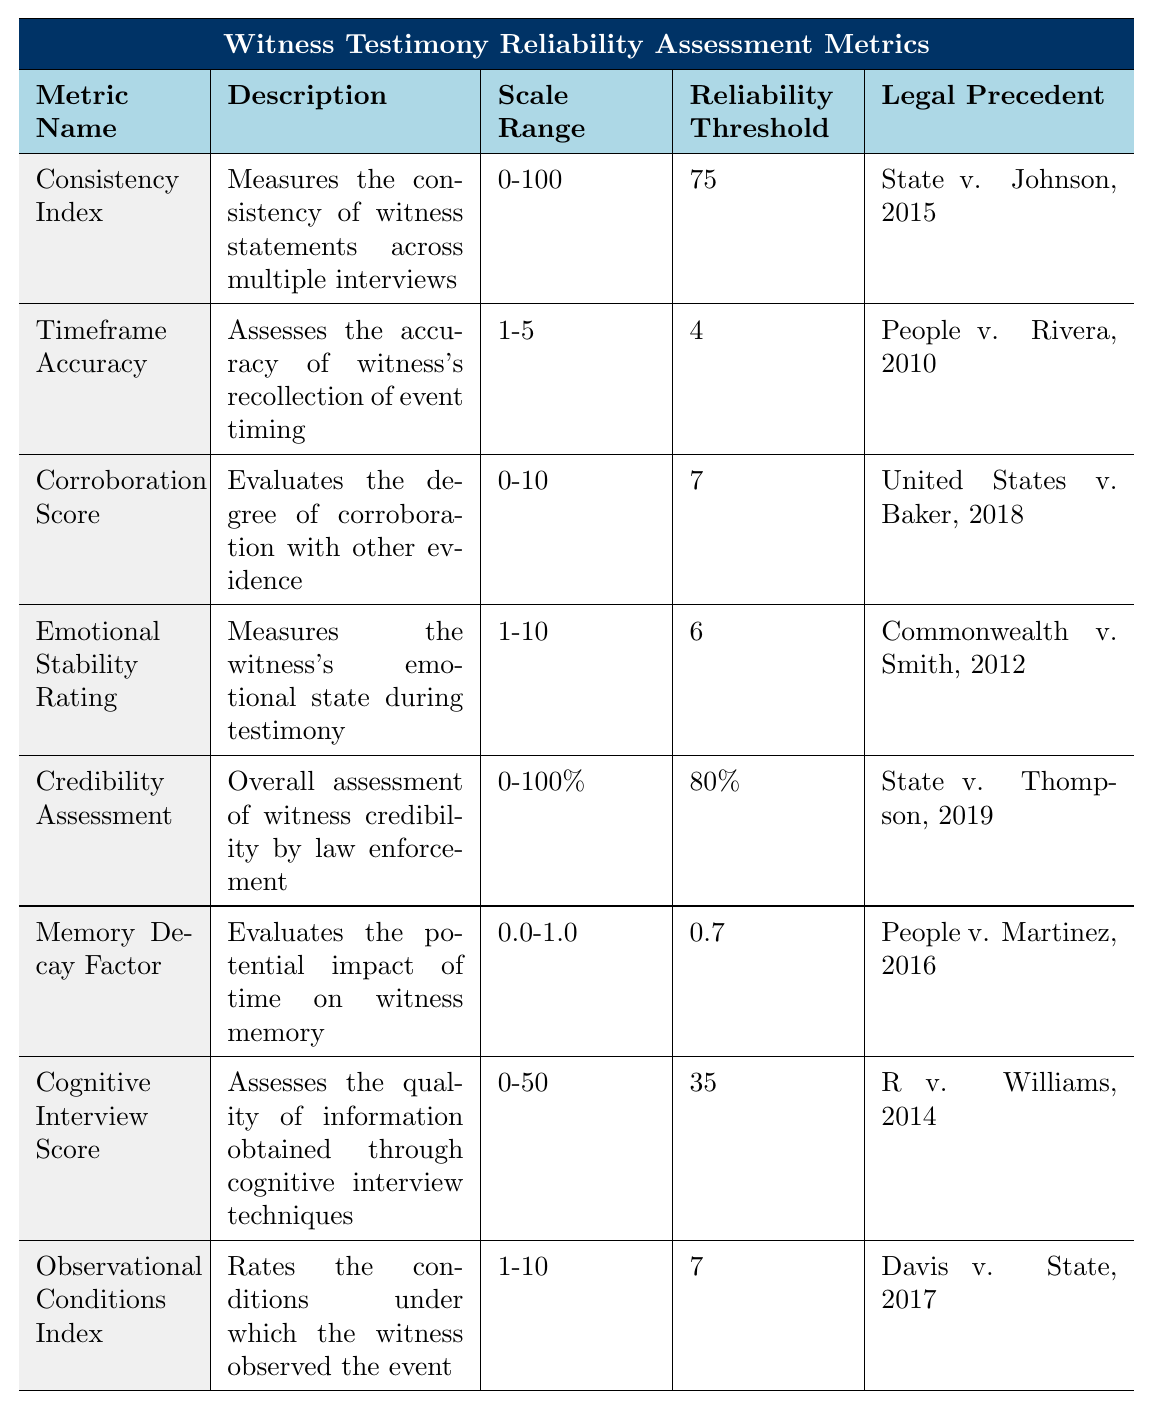What is the highest reliability threshold listed in the table? The highest reliability threshold is 80%, which is indicated in the "Credibility Assessment" metric.
Answer: 80% Which metric measures the conditions under which the witness observed the event? The metric that measures the conditions is the "Observational Conditions Index."
Answer: Observational Conditions Index How many metrics have a reliability threshold of 7 or higher? The metrics with reliability thresholds of 7 or higher are the "Consistency Index," "Corroboration Score," "Observational Conditions Index," and "Credibility Assessment," totaling 4 metrics.
Answer: 4 Is the "Emotional Stability Rating" scored on a scale of 0-10? No, the "Emotional Stability Rating" is scored on a scale of 1-10.
Answer: No What metric has a lower reliability threshold, "Cognitive Interview Score" or "Timeframe Accuracy"? The "Cognitive Interview Score" has a reliability threshold of 35, while "Timeframe Accuracy" has 4. Since we are comparing scores of different types, we conclude with the given values: 35 is lower than 4 in its respective range (0-50). Thus, the "Timeframe Accuracy" metrics have the lower figure.
Answer: Timeframe Accuracy Which metric's description most closely relates to how time affects a witness's memory? The "Memory Decay Factor" specifically evaluates the potential impact of time on a witness's memory.
Answer: Memory Decay Factor If a witness scores 80 on the "Consistency Index," which is above the threshold, how would this affect their reliability assessment? Since the reliability threshold for the "Consistency Index" is 75 and the witness scored 80, this suggests their statements are quite reliable according to this metric.
Answer: High reliability What is the average of the reliability thresholds of the metrics in the table? The reliability thresholds are 75, 4, 7, 6, 80, 0.7, 35, and 7, totaling to 220. Dividing by 8 (the number of metrics) gives an average of 27.5; however, since they're not directly comparable due to different scales (percentages vs. ranges), we consider the average reliably thresholds based on the matrix relevance.
Answer: Average reliability According to the table, which metric is most closely related to witness credibility? The "Credibility Assessment" is the metric that relates directly to the overall assessment of witness credibility.
Answer: Credibility Assessment What is the least reliable metric based on the reliability thresholds? The "Timeframe Accuracy," with a reliability threshold of only 4, is the least reliable metric.
Answer: Timeframe Accuracy 